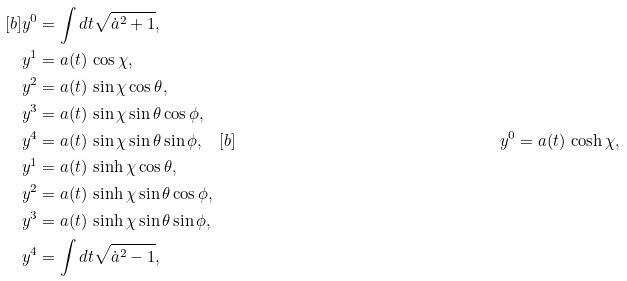<formula> <loc_0><loc_0><loc_500><loc_500>[ b ] & y ^ { 0 } = \int d t \sqrt { \dot { a } ^ { 2 } + 1 } , \\ & y ^ { 1 } = a ( t ) \, \cos \chi , \\ & y ^ { 2 } = a ( t ) \, \sin \chi \cos \theta , \\ & y ^ { 3 } = a ( t ) \, \sin \chi \sin \theta \cos \phi , \\ & y ^ { 4 } = a ( t ) \, \sin \chi \sin \theta \sin \phi , \quad [ b ] & y ^ { 0 } = a ( t ) \, \cosh \chi , \\ & y ^ { 1 } = a ( t ) \, \sinh \chi \cos \theta , \\ & y ^ { 2 } = a ( t ) \, \sinh \chi \sin \theta \cos \phi , \\ & y ^ { 3 } = a ( t ) \, \sinh \chi \sin \theta \sin \phi , \\ & y ^ { 4 } = \int d t \sqrt { \dot { a } ^ { 2 } - 1 } ,</formula> 